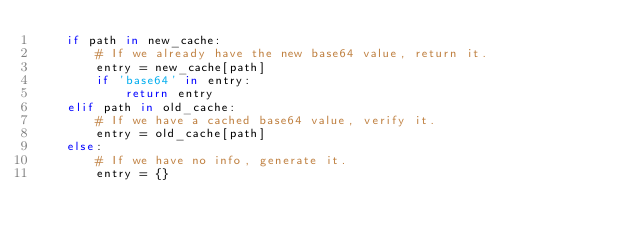Convert code to text. <code><loc_0><loc_0><loc_500><loc_500><_Python_>    if path in new_cache:
        # If we already have the new base64 value, return it.
        entry = new_cache[path]
        if 'base64' in entry:
            return entry
    elif path in old_cache:
        # If we have a cached base64 value, verify it.
        entry = old_cache[path]
    else:
        # If we have no info, generate it.
        entry = {}
</code> 